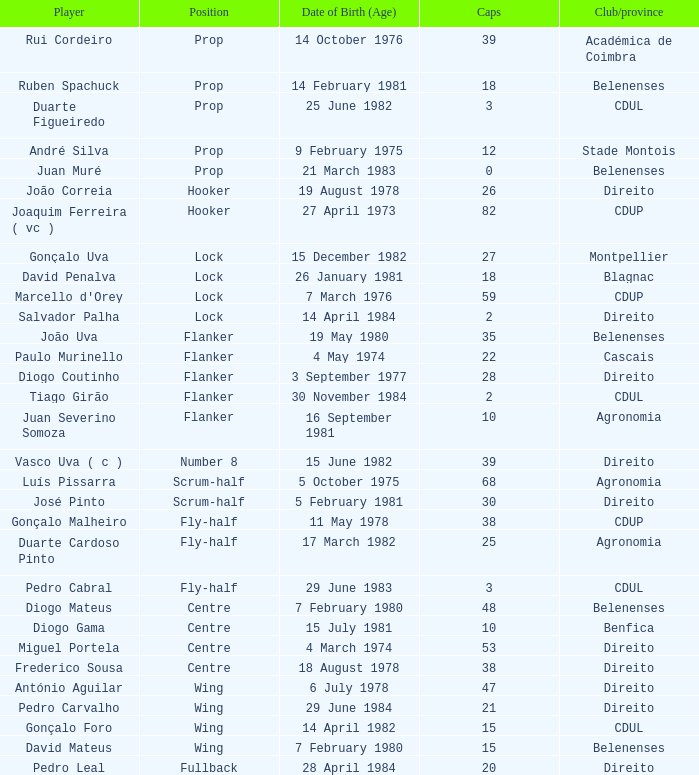How many caps were born on july 15, 1981 (age)? 1.0. 